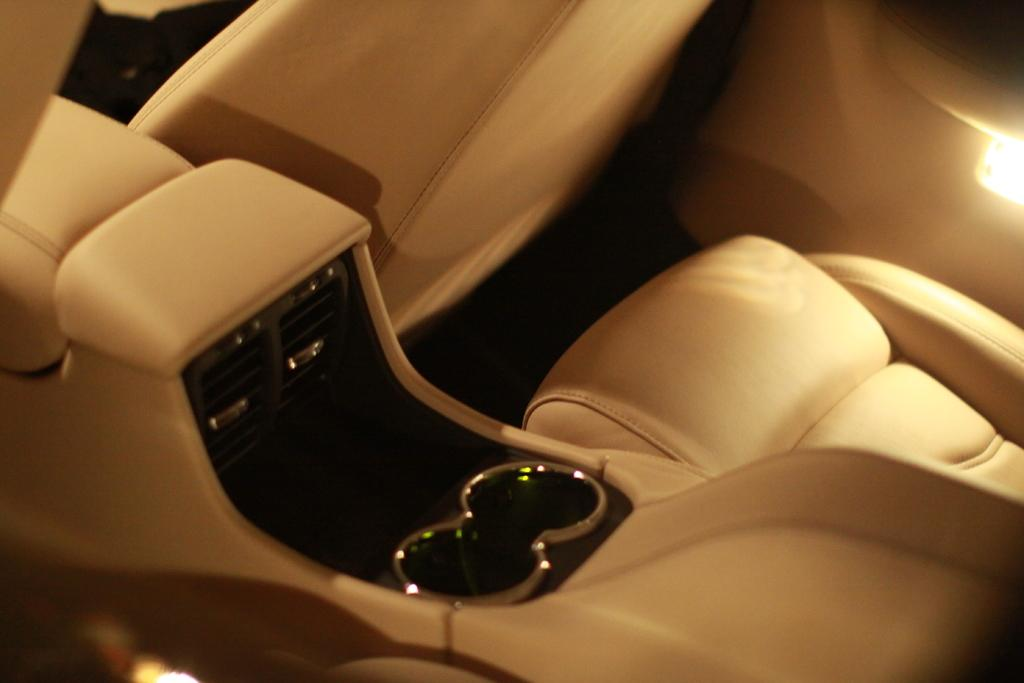What type of location is depicted in the image? The image is of the inside part of a car. What can be found inside the car? There are seats in the car. Is there any source of light visible in the image? Yes, there is a light on the right side of the image. What type of plot is being developed in the image? The image does not depict a plot or story; it is a photograph of the inside of a car. Can you see any kittens playing with oranges in the image? No, there are no kittens or oranges present in the image. 